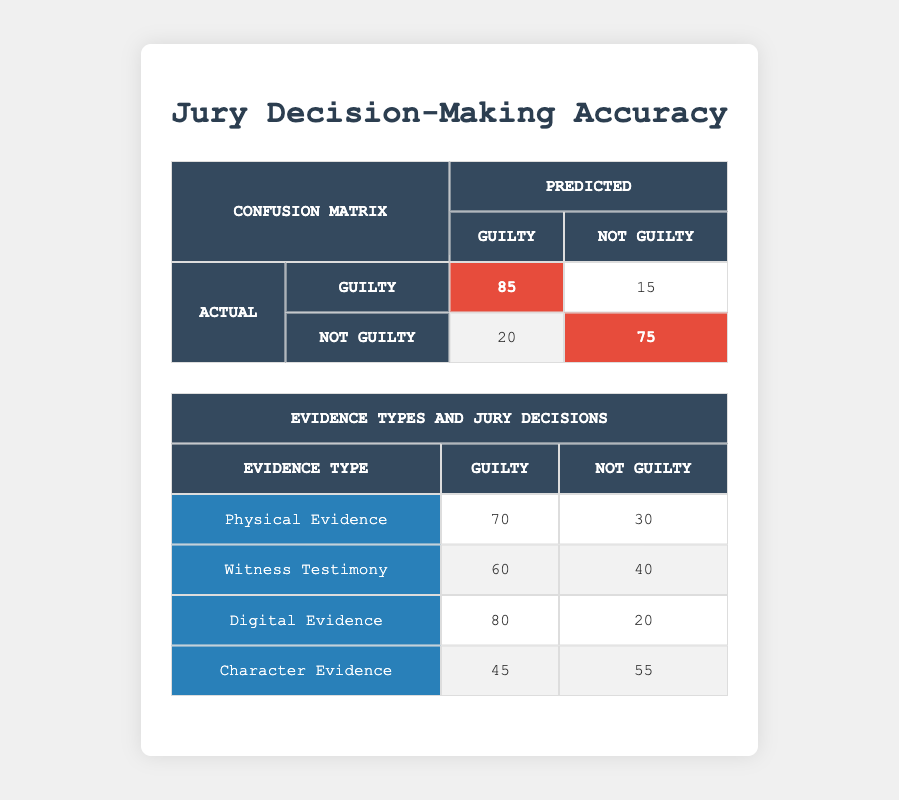What is the number of actual convictions of guilty based on jury decisions? According to the confusion matrix, the number of actual guilty convictions is represented in the first row under the actual verdict "Guilty," which shows that there were 85 instances where the jury predicted "Guilty" for the actual "Guilty."
Answer: 85 What proportion of the jury's decisions were correct when the actual verdict was not guilty? To determine this, we refer to the second row in the confusion matrix where the actual verdict is "Not Guilty." The jury made a correct decision (predicted "Not Guilty") in 75 instances. The total actual "Not Guilty" cases is the sum of the values in that row: 20 (predicted "Guilty") + 75 (predicted "Not Guilty") = 95. The proportion is 75/95 = 0.7895 or approximately 79%.
Answer: 79% How many times did the jury incorrectly identify a guilty verdict when the actual verdict was not guilty? This can be found in the confusion matrix under the row for "Not Guilty" and the column for "Guilty." The value there is 20, indicating that the jury incorrectly identified 20 cases as "Guilty" when they were actually "Not Guilty."
Answer: 20 Which type of evidence led to the highest number of jury decisions resulting in a guilty verdict? To find this, we look at the evidence types table and compare the numbers in the "Guilty" column. The highest value is found for "Digital Evidence," where the jury decided guilty in 80 instances.
Answer: Digital Evidence What is the overall rate of false guilty verdicts, and how is it calculated? The overall rate of false guilty verdicts can be calculated using the confusion matrix. False guilty verdicts occur when the actual verdict is "Not Guilty" but predicted as "Guilty," which is the value 20. The total number of actual "Not Guilty" cases is 95. Therefore, the rate is 20/95, which is approximately 0.2105 or 21%.
Answer: 21% What is the difference in the number of guilty verdicts based on physical evidence versus witness testimony? From the evidence types table, the number of guilty verdicts based on "Physical Evidence" is 70, while for "Witness Testimony," it is 60. The difference is 70 - 60 = 10.
Answer: 10 Based on character evidence, did the jury favor a guilty verdict more than a not guilty verdict? In the evidence types table, for "Character Evidence," the jury had 45 guilty decisions and 55 not guilty decisions. Since 45 is less than 55, the jury did not favor a guilty verdict.
Answer: No Which evidence type has the highest discrepancy between guilty and not guilty verdicts? To calculate the discrepancies, we compare the absolute differences in each evidence type. For "Physical Evidence," the difference is 40 (70 - 30), for "Witness Testimony," it is 20 (60 - 40), for "Digital Evidence," it is 60 (80 - 20), and for "Character Evidence," it is 10 (55 - 45). The highest discrepancy is for "Digital Evidence."
Answer: Digital Evidence 